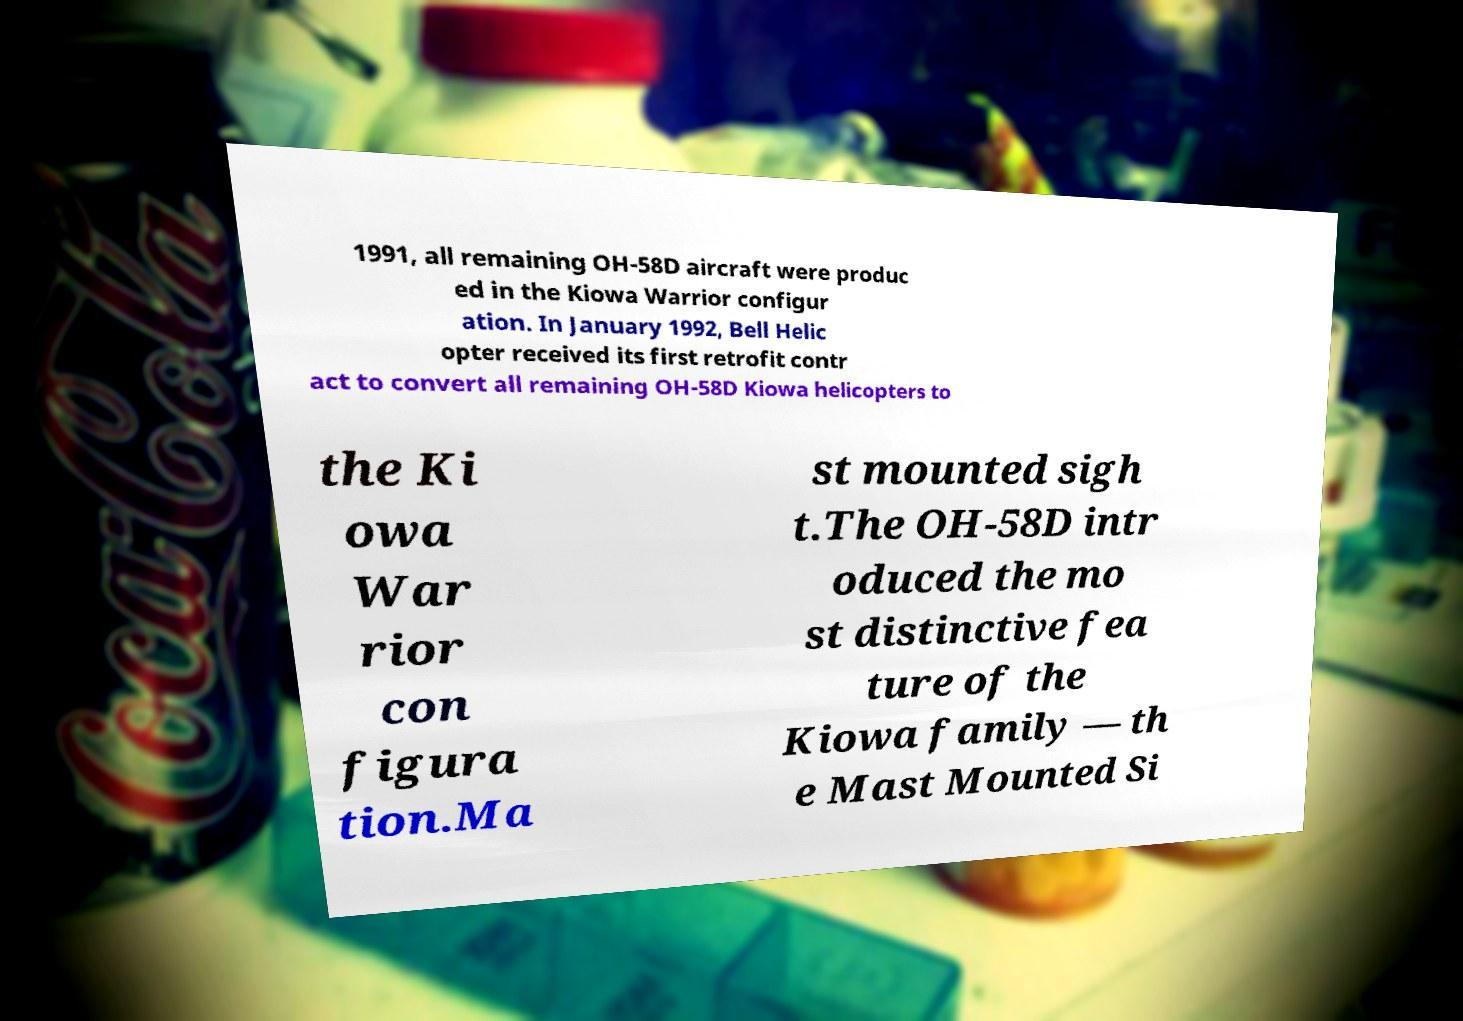I need the written content from this picture converted into text. Can you do that? 1991, all remaining OH-58D aircraft were produc ed in the Kiowa Warrior configur ation. In January 1992, Bell Helic opter received its first retrofit contr act to convert all remaining OH-58D Kiowa helicopters to the Ki owa War rior con figura tion.Ma st mounted sigh t.The OH-58D intr oduced the mo st distinctive fea ture of the Kiowa family — th e Mast Mounted Si 